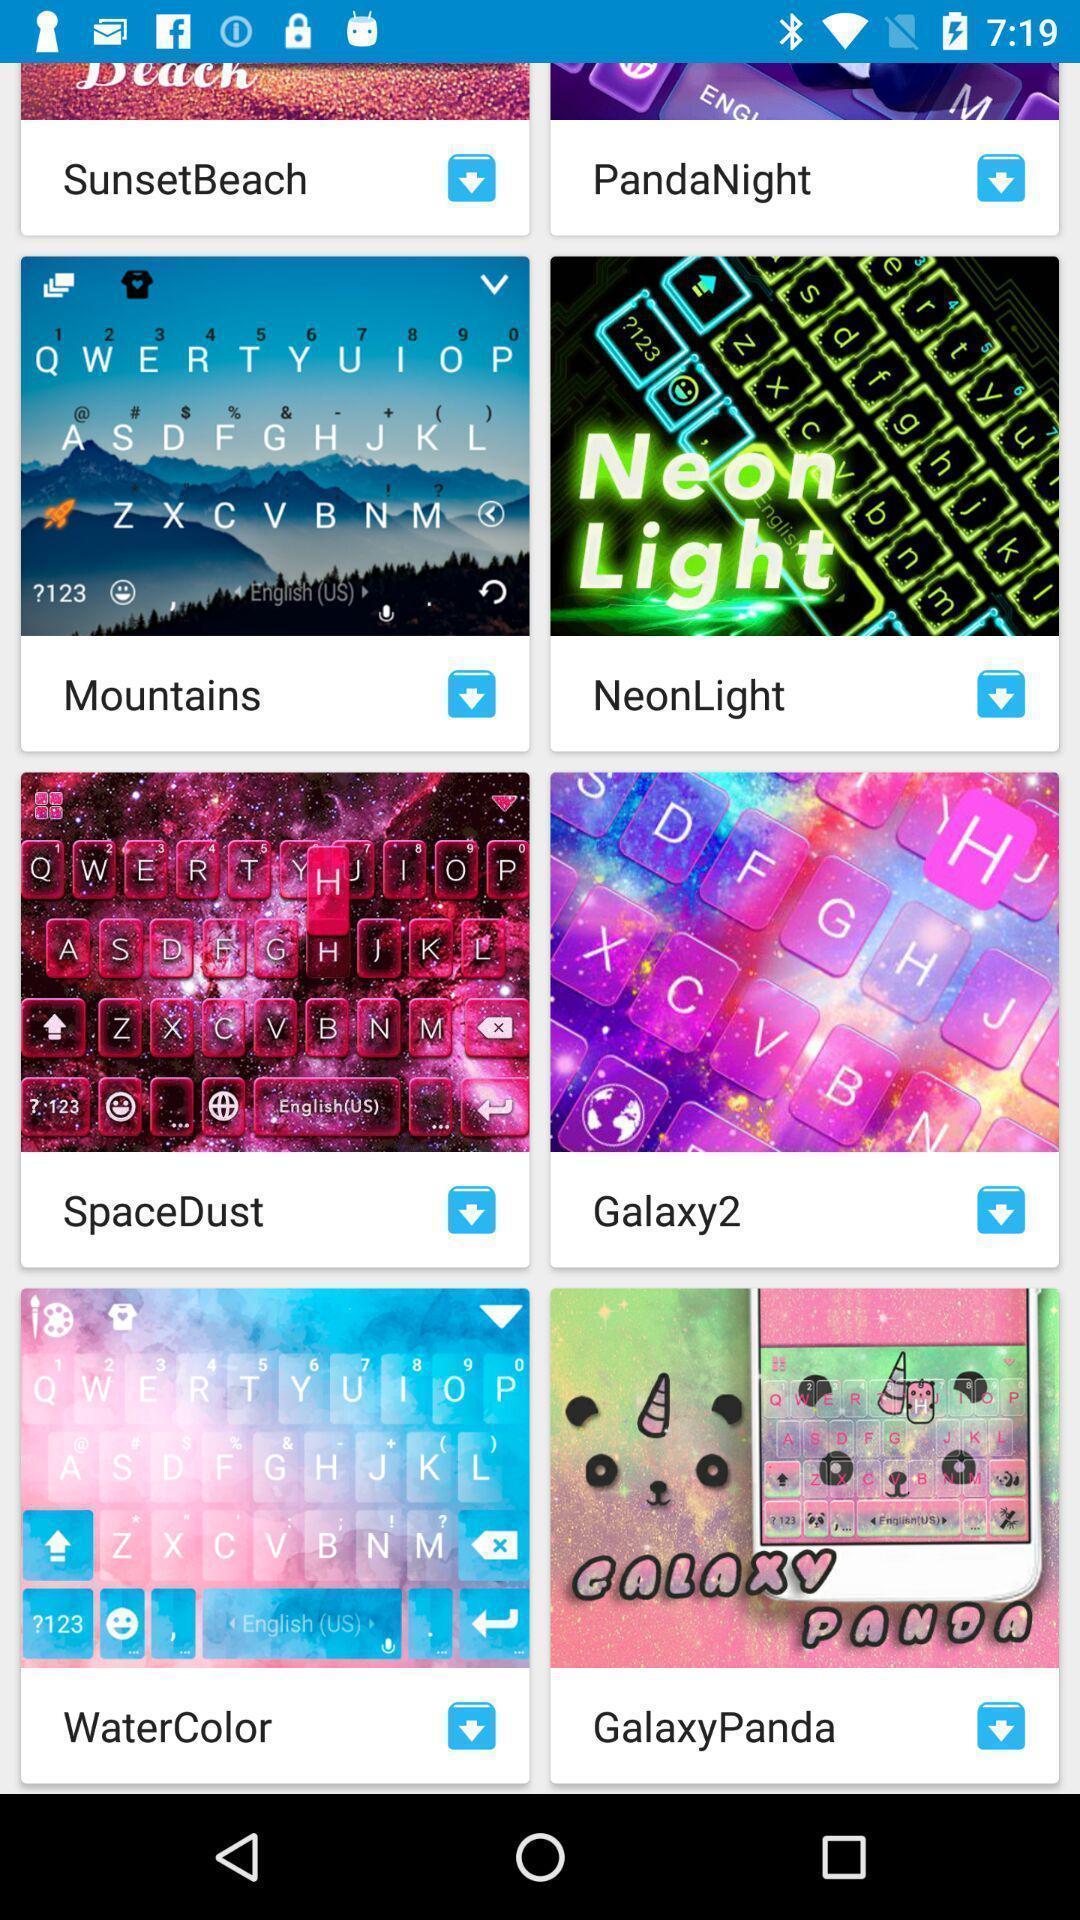Give me a summary of this screen capture. Screen shows about different themes. 